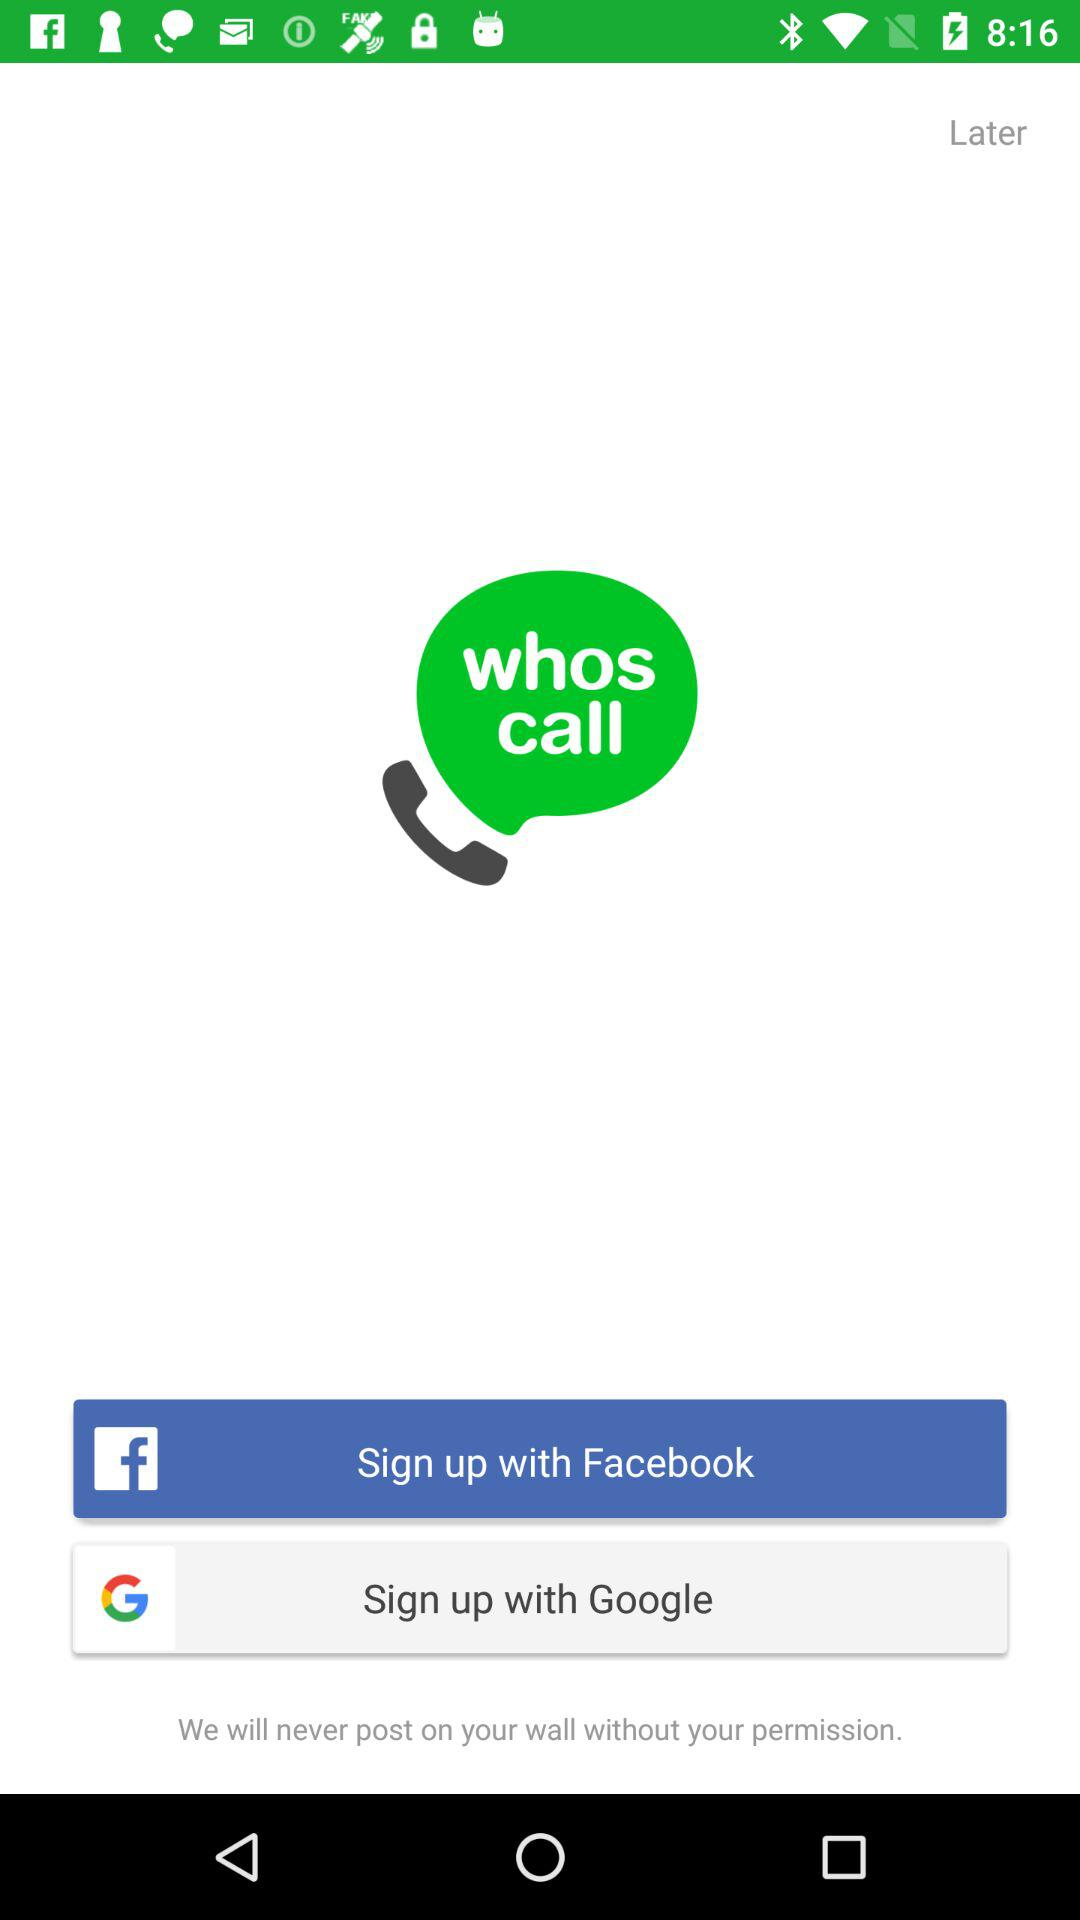How long does it take to sign up with "Google"?
When the provided information is insufficient, respond with <no answer>. <no answer> 